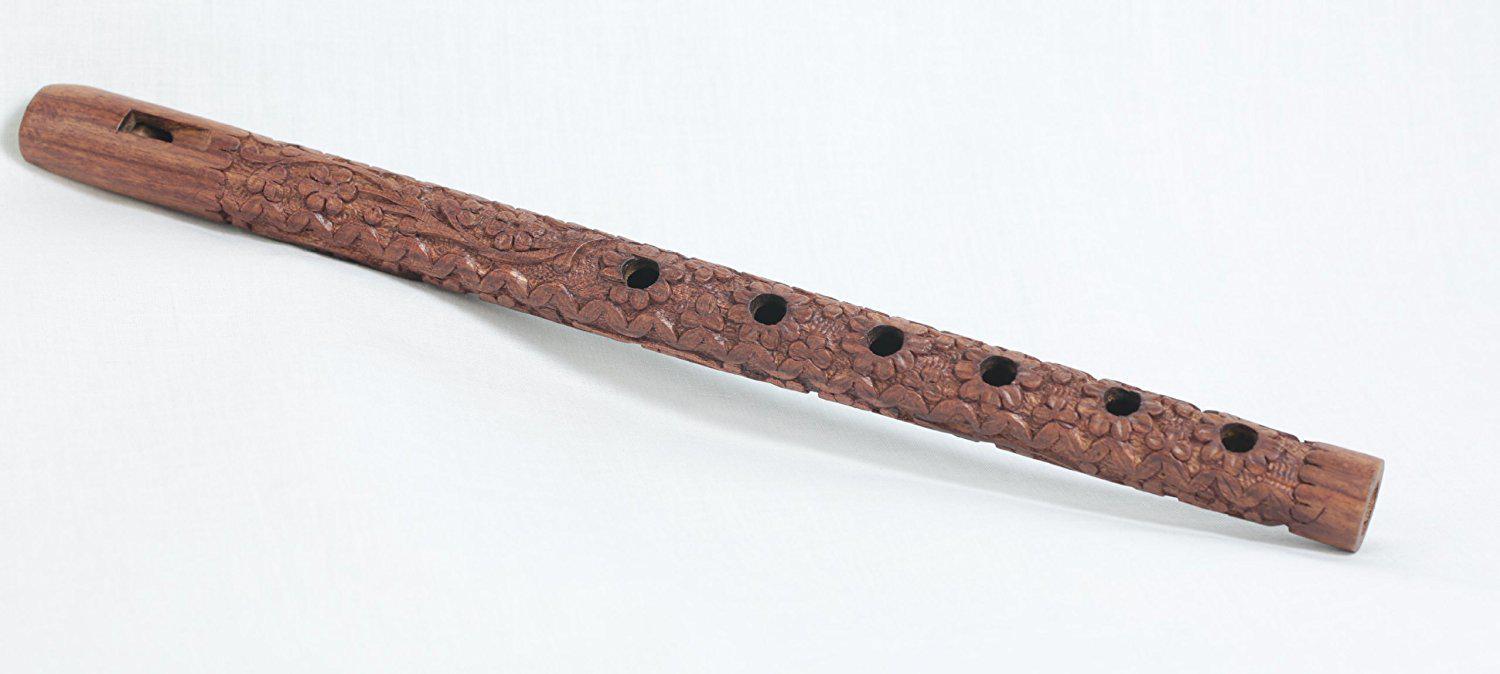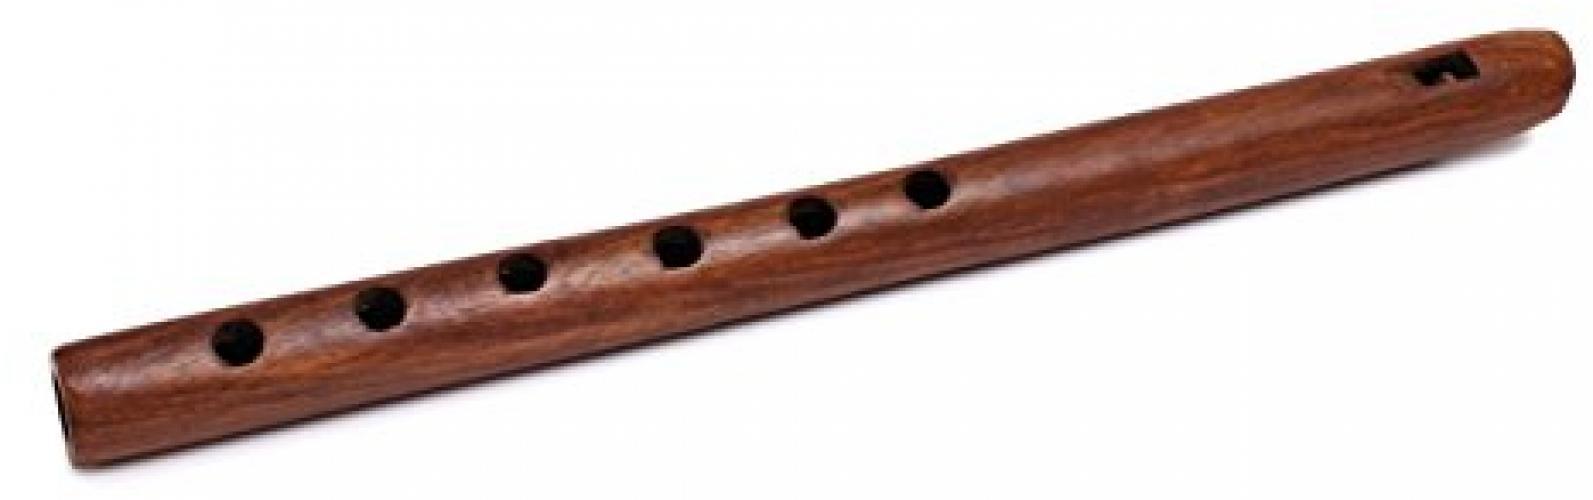The first image is the image on the left, the second image is the image on the right. Given the left and right images, does the statement "There are a total of two flutes facing opposite directions." hold true? Answer yes or no. Yes. 